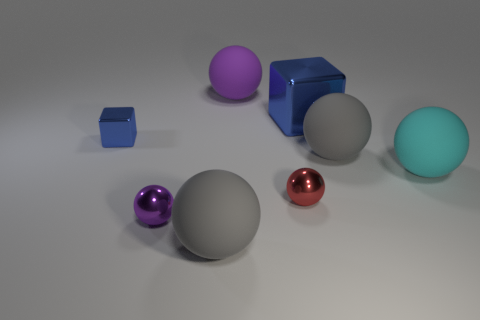Which objects in this image have reflective surfaces? The objects with reflective surfaces in the image include the blue metallic cube, the small red sphere, and the purple sphere. These objects have a shiny appearance that indicates their reflective quality, setting them apart from the matte-finished objects. 